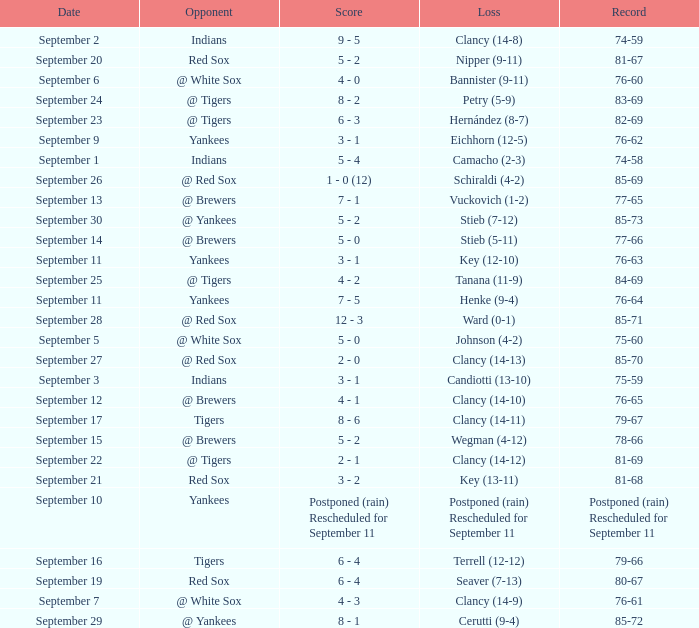Who was the Blue Jays opponent when their record was 84-69? @ Tigers. 